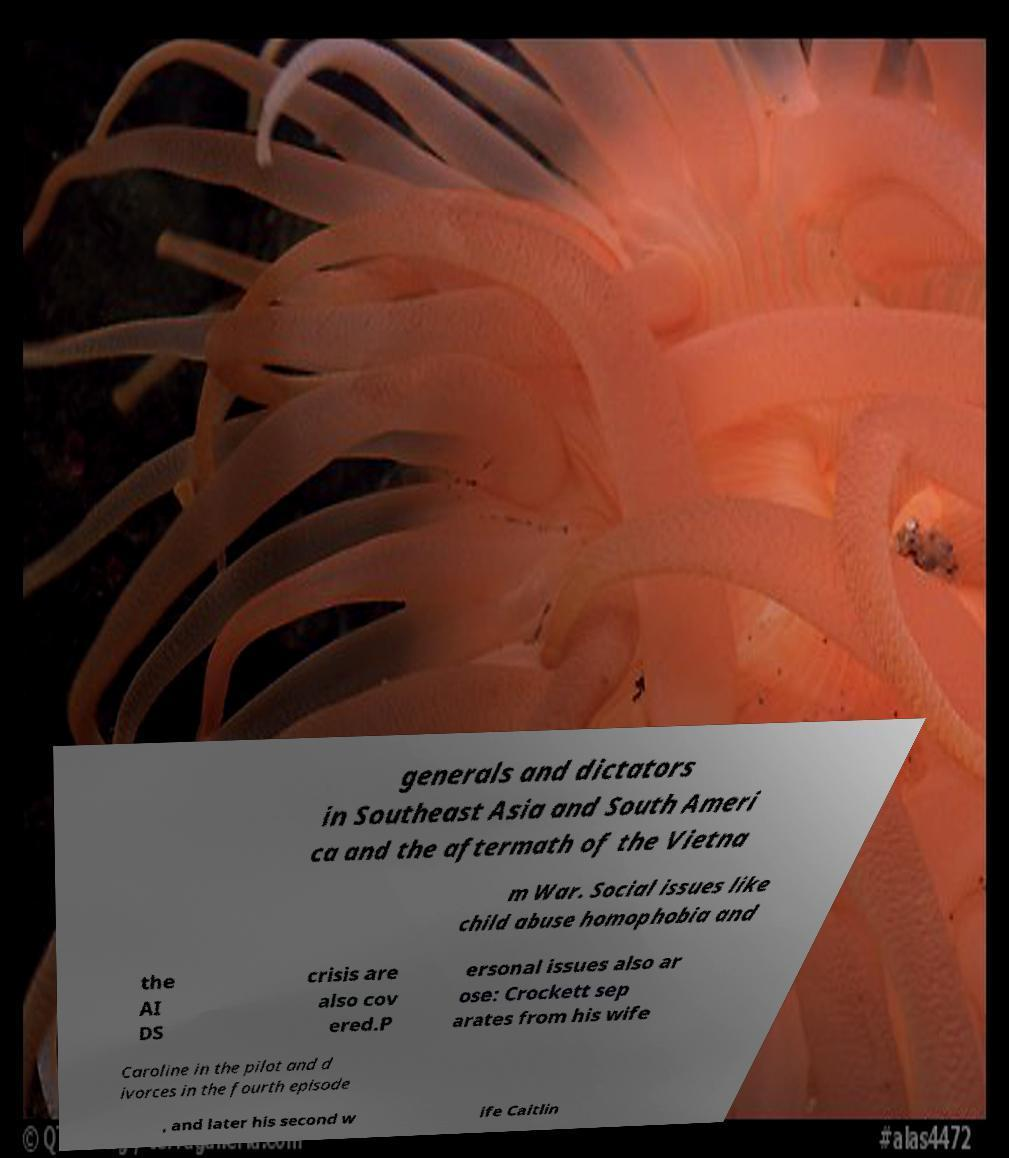Can you read and provide the text displayed in the image?This photo seems to have some interesting text. Can you extract and type it out for me? generals and dictators in Southeast Asia and South Ameri ca and the aftermath of the Vietna m War. Social issues like child abuse homophobia and the AI DS crisis are also cov ered.P ersonal issues also ar ose: Crockett sep arates from his wife Caroline in the pilot and d ivorces in the fourth episode , and later his second w ife Caitlin 